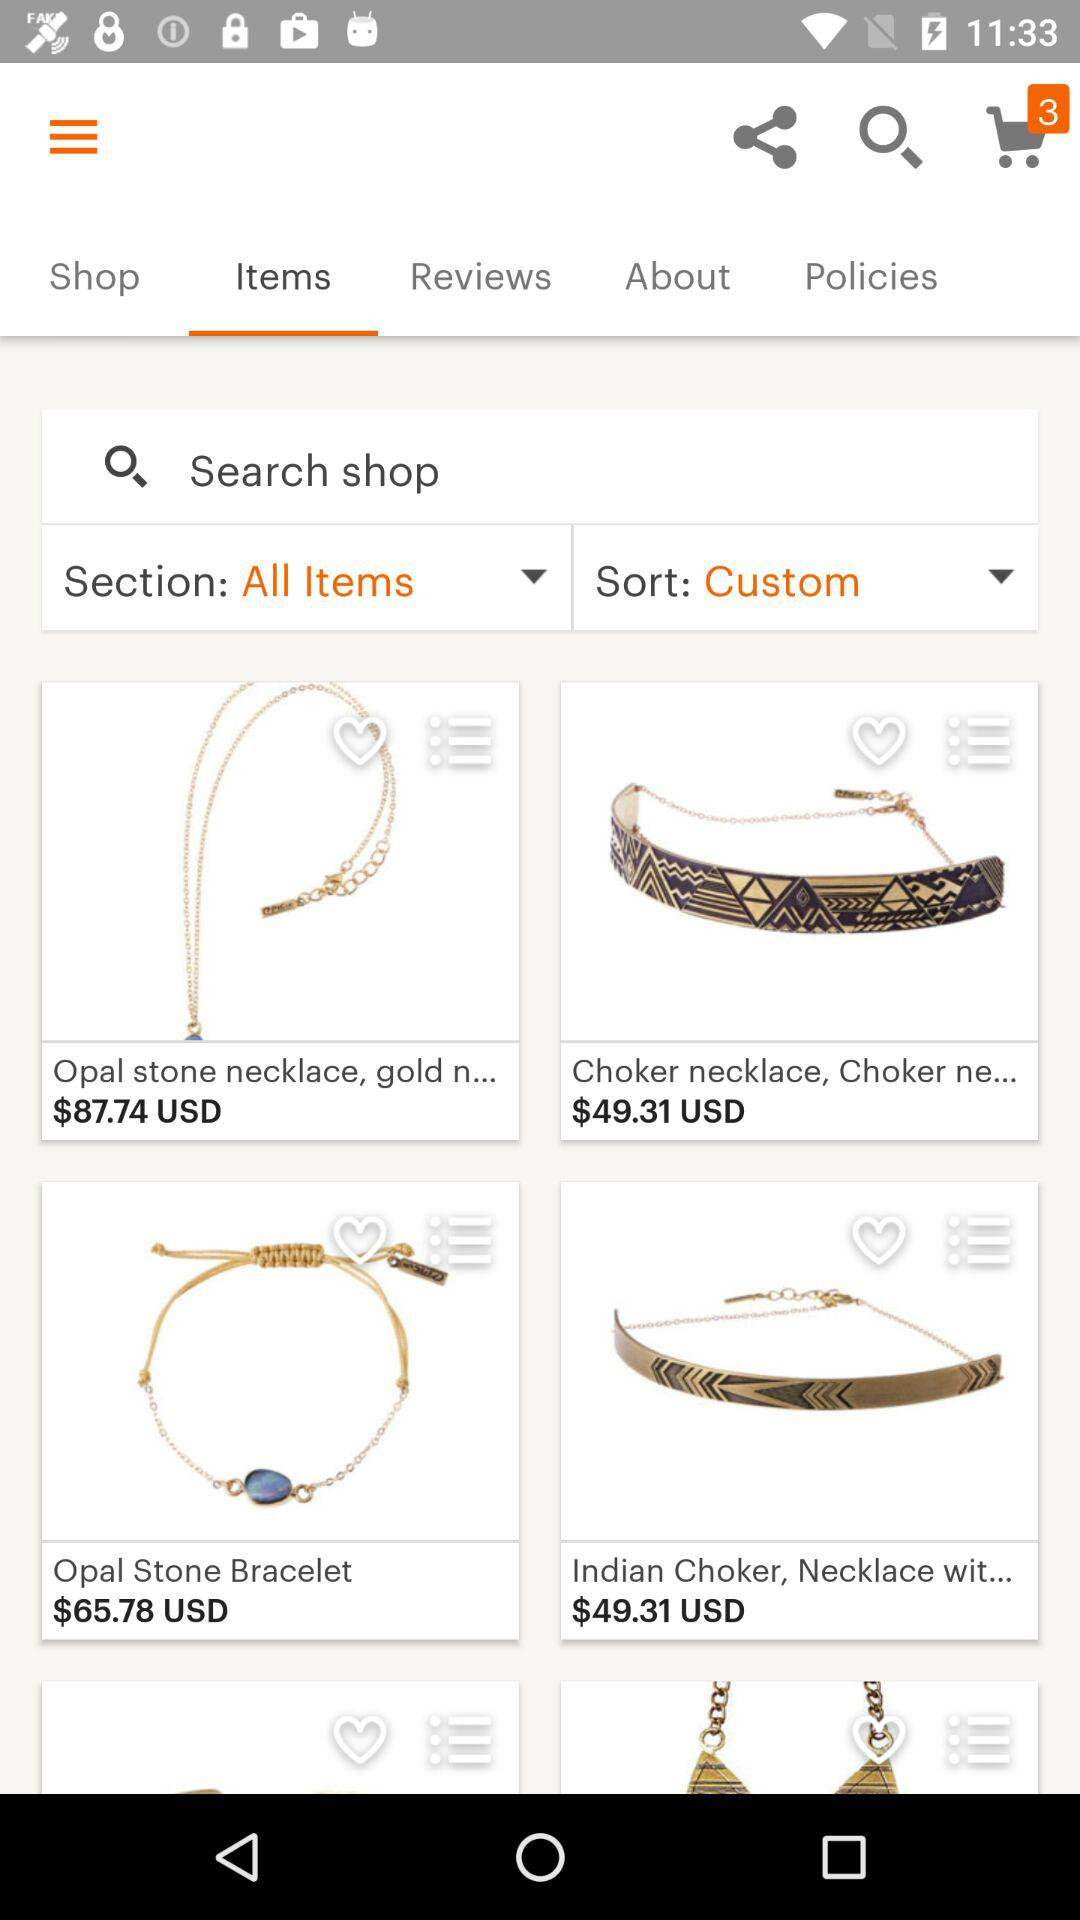How much is the most expensive item on the first row?
Answer the question using a single word or phrase. $87.74 USD 